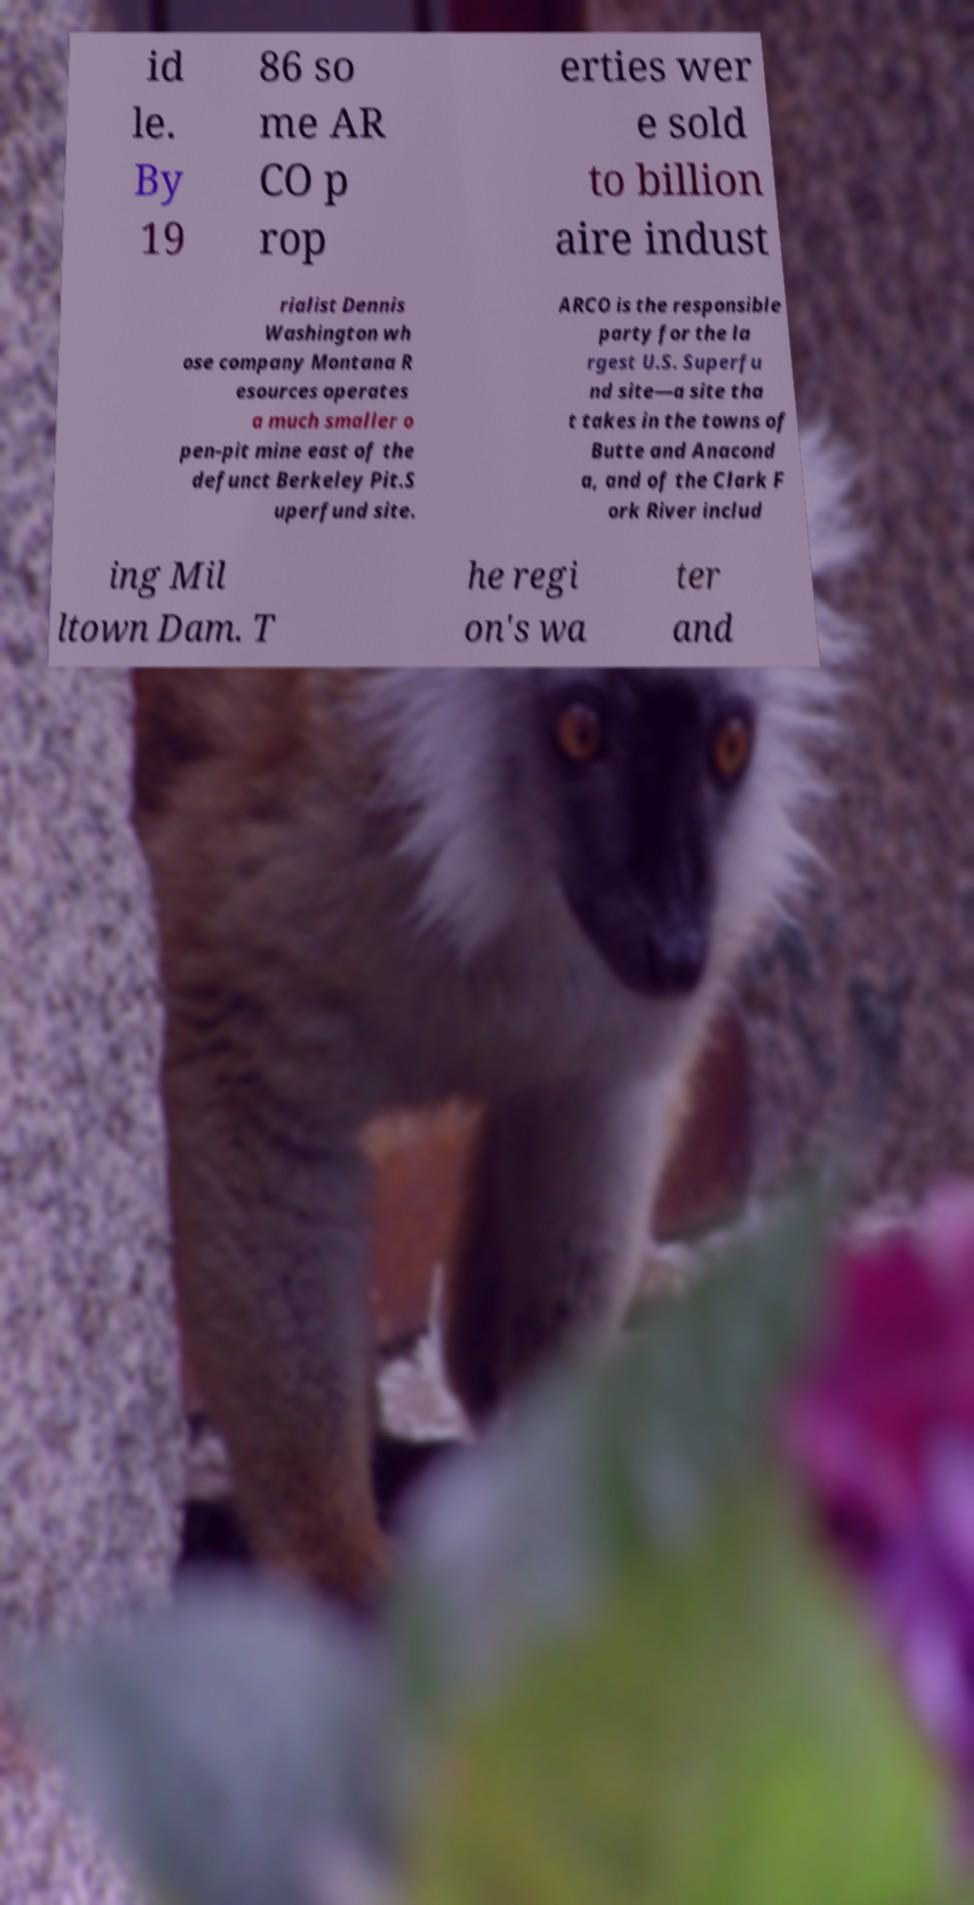For documentation purposes, I need the text within this image transcribed. Could you provide that? id le. By 19 86 so me AR CO p rop erties wer e sold to billion aire indust rialist Dennis Washington wh ose company Montana R esources operates a much smaller o pen-pit mine east of the defunct Berkeley Pit.S uperfund site. ARCO is the responsible party for the la rgest U.S. Superfu nd site—a site tha t takes in the towns of Butte and Anacond a, and of the Clark F ork River includ ing Mil ltown Dam. T he regi on's wa ter and 